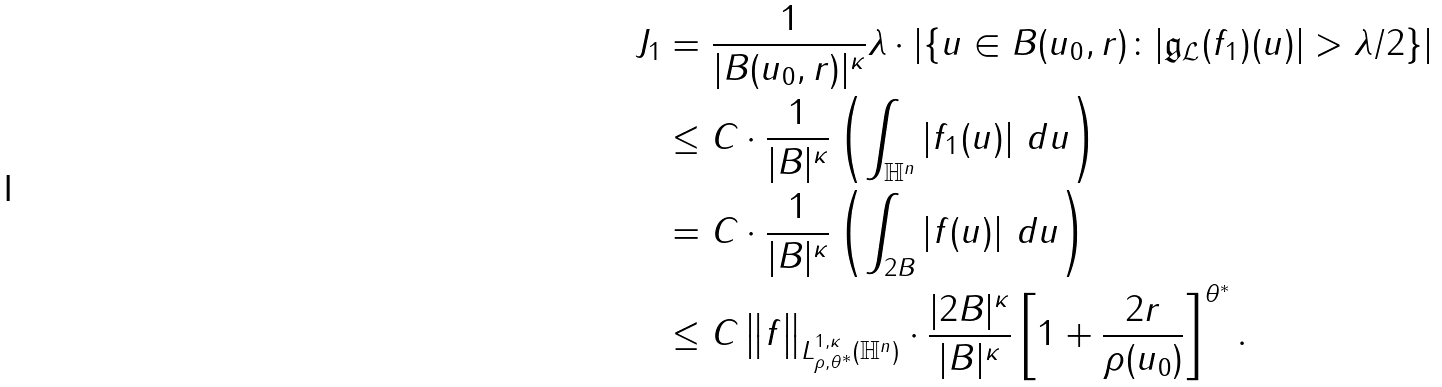Convert formula to latex. <formula><loc_0><loc_0><loc_500><loc_500>J _ { 1 } & = \frac { 1 } { | B ( u _ { 0 } , r ) | ^ { \kappa } } \lambda \cdot \left | \left \{ u \in B ( u _ { 0 } , r ) \colon | \mathfrak { g } _ { \mathcal { L } } ( f _ { 1 } ) ( u ) | > \lambda / 2 \right \} \right | \\ & \leq C \cdot \frac { 1 } { | B | ^ { \kappa } } \left ( \int _ { \mathbb { H } ^ { n } } \left | f _ { 1 } ( u ) \right | \, d u \right ) \\ & = C \cdot \frac { 1 } { | B | ^ { \kappa } } \left ( \int _ { 2 B } \left | f ( u ) \right | \, d u \right ) \\ & \leq C \left \| f \right \| _ { L ^ { 1 , \kappa } _ { \rho , \theta ^ { * } } ( \mathbb { H } ^ { n } ) } \cdot \frac { | 2 B | ^ { \kappa } } { | B | ^ { \kappa } } \left [ 1 + \frac { 2 r } { \rho ( u _ { 0 } ) } \right ] ^ { \theta ^ { * } } .</formula> 